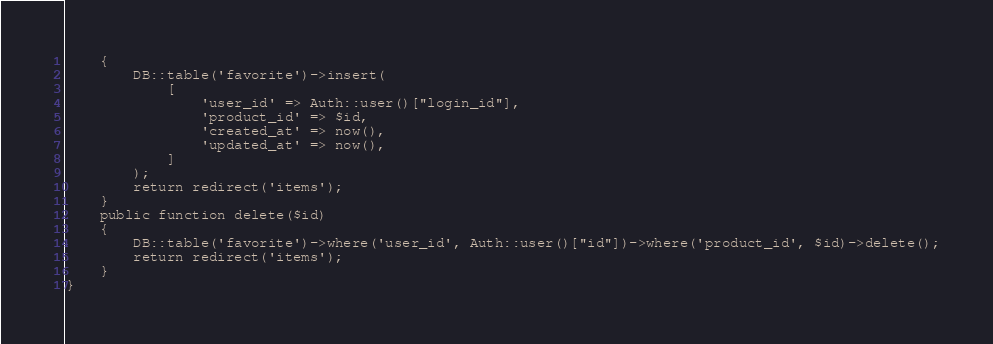Convert code to text. <code><loc_0><loc_0><loc_500><loc_500><_PHP_>    {
        DB::table('favorite')->insert(
            [
                'user_id' => Auth::user()["login_id"],
                'product_id' => $id,
                'created_at' => now(),
                'updated_at' => now(),
            ]
        );
        return redirect('items');
    }
    public function delete($id)
    {
        DB::table('favorite')->where('user_id', Auth::user()["id"])->where('product_id', $id)->delete();
        return redirect('items');
    }
}
</code> 